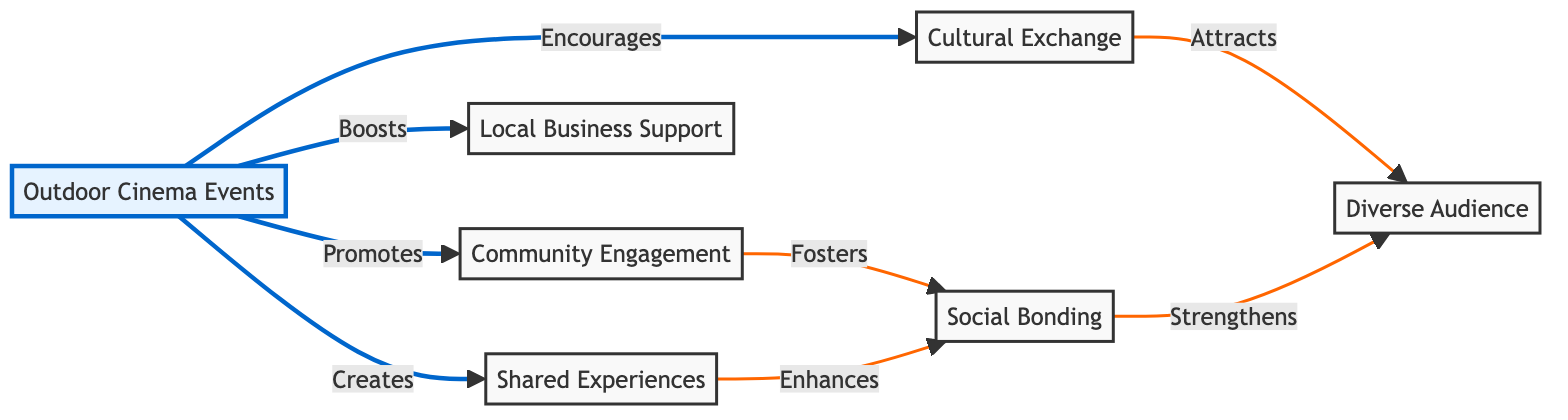What is the primary role of outdoor cinema events according to the diagram? The node labeled "Outdoor Cinema Events" is directly connected to the node "Community Engagement" with the label "Promotes." Therefore, the primary role is to promote community engagement.
Answer: promote community engagement How many main nodes are represented in the diagram? The diagram contains seven main nodes: Outdoor Cinema Events, Community Engagement, Social Bonding, Cultural Exchange, Local Business Support, Shared Experiences, and Diverse Audience. Thus, there are seven main nodes.
Answer: seven What relationship exists between community engagement and social bonding? The relationship is indicated by a directed arrow from "Community Engagement" to "Social Bonding" with the label "Fosters," showing that community engagement fosters social bonding.
Answer: fosters Which node receives support directly from the outdoor cinema events? The node "Local Business Support" is connected to "Outdoor Cinema Events" with the label "Boosts," indicating that local businesses receive support from these events.
Answer: boosts What does "Shared Experiences" enhance according to the diagram? "Shared Experiences" is connected to "Social Bonding" with the label "Enhances," meaning that it enhances social bonding.
Answer: enhances social bonding How does cultural exchange relate to the audience type? The arrow from "Cultural Exchange" to "Diverse Audience" with the label "Attracts" indicates that cultural exchange attracts a diverse audience.
Answer: attracts a diverse audience What is the effect of shared experiences on social bonding? The directed arrow from "Shared Experiences" to "Social Bonding" shows that shared experiences enhance social bonding, thus positively affecting it.
Answer: enhances social bonding What is the connection type between outdoor cinema events and community engagement? The connection is labeled as "Promotes," indicating a direct influence of outdoor cinema events on community engagement.
Answer: promotes 